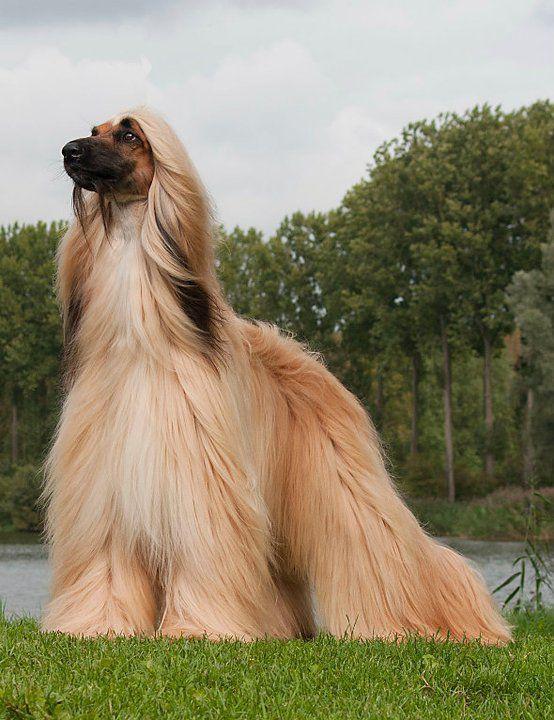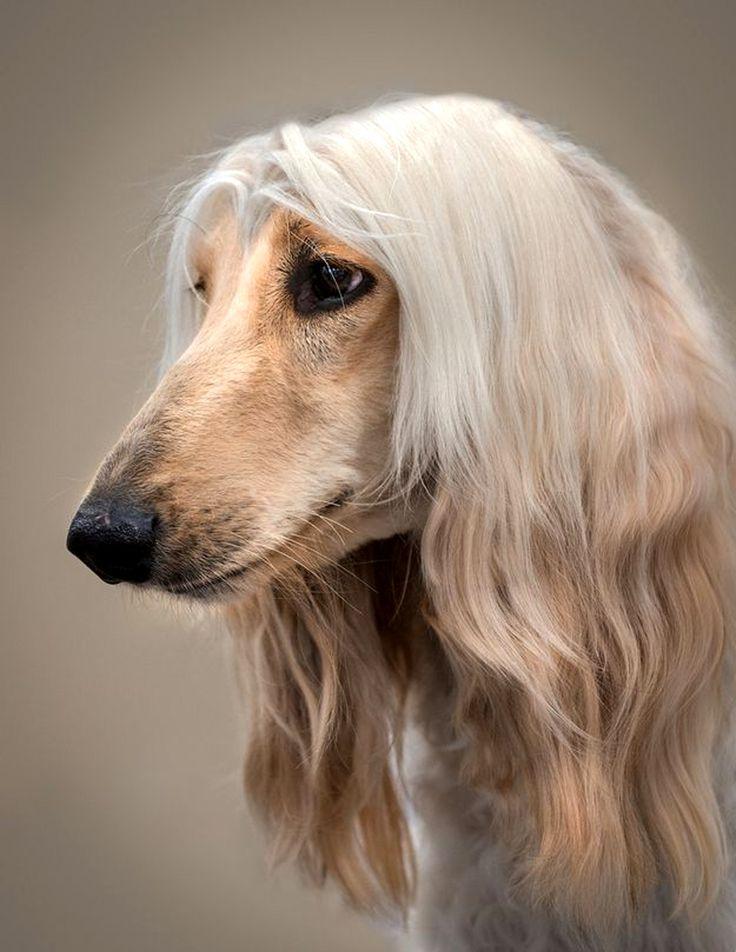The first image is the image on the left, the second image is the image on the right. Assess this claim about the two images: "Each image contains one afghan hound with light-orangish hair who is gazing to the left, and one of the depicted dogs is standing on all fours.". Correct or not? Answer yes or no. Yes. The first image is the image on the left, the second image is the image on the right. Given the left and right images, does the statement "Both dogs' mouths are open." hold true? Answer yes or no. No. 